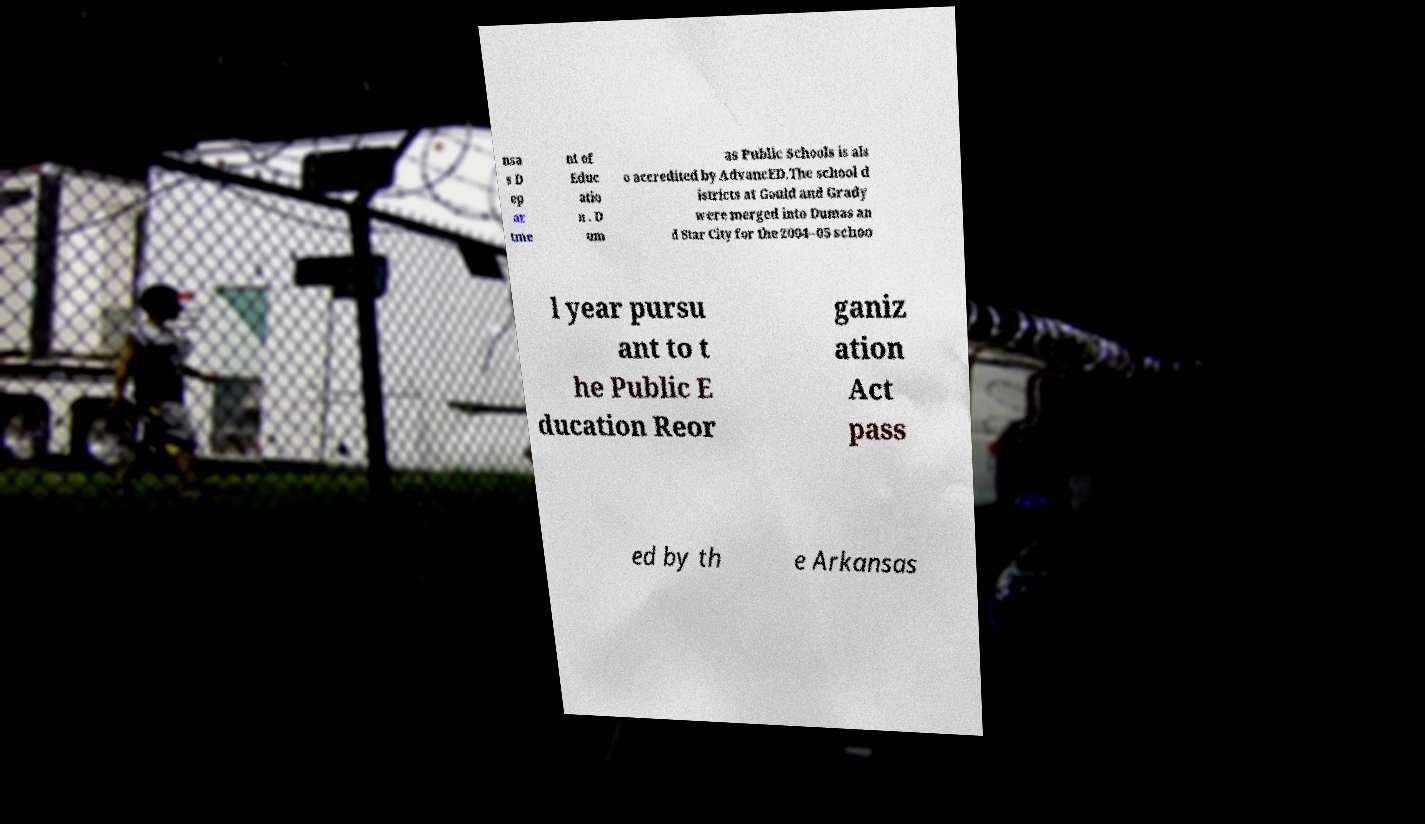Can you accurately transcribe the text from the provided image for me? nsa s D ep ar tme nt of Educ atio n . D um as Public Schools is als o accredited by AdvancED.The school d istricts at Gould and Grady were merged into Dumas an d Star City for the 2004–05 schoo l year pursu ant to t he Public E ducation Reor ganiz ation Act pass ed by th e Arkansas 